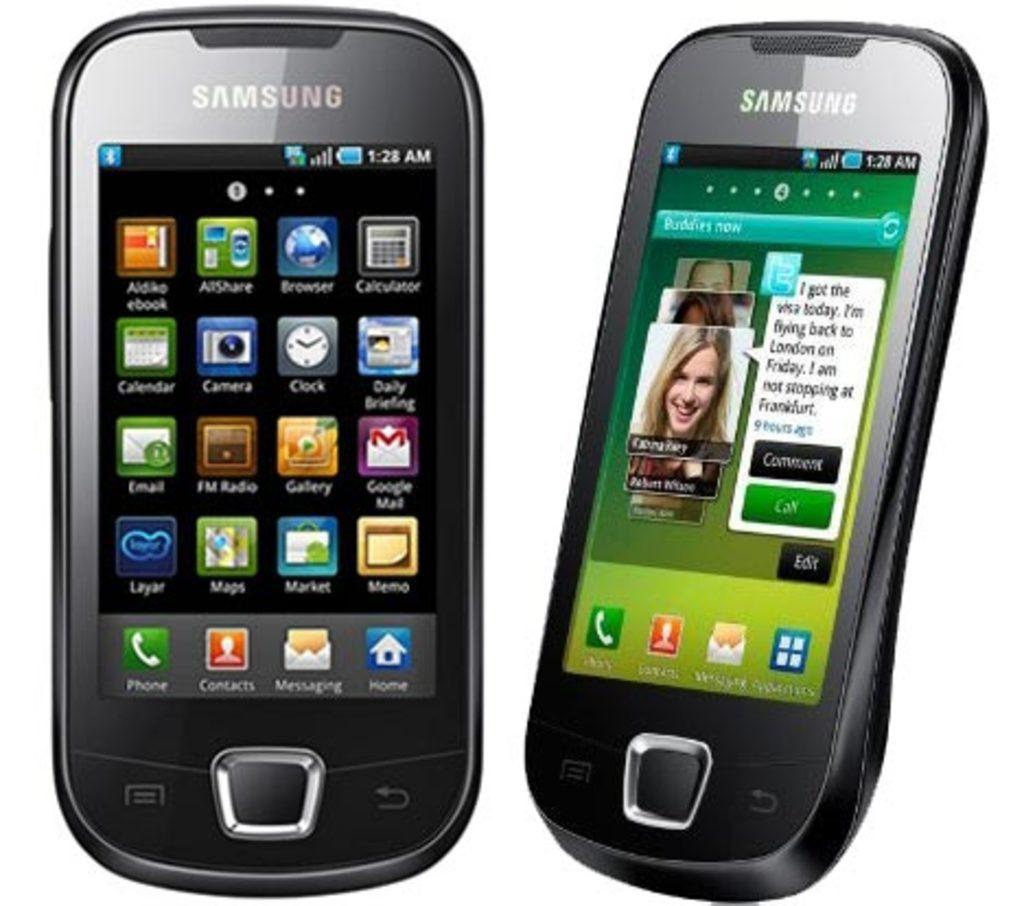<image>
Summarize the visual content of the image. two phones with one that has a call sign 